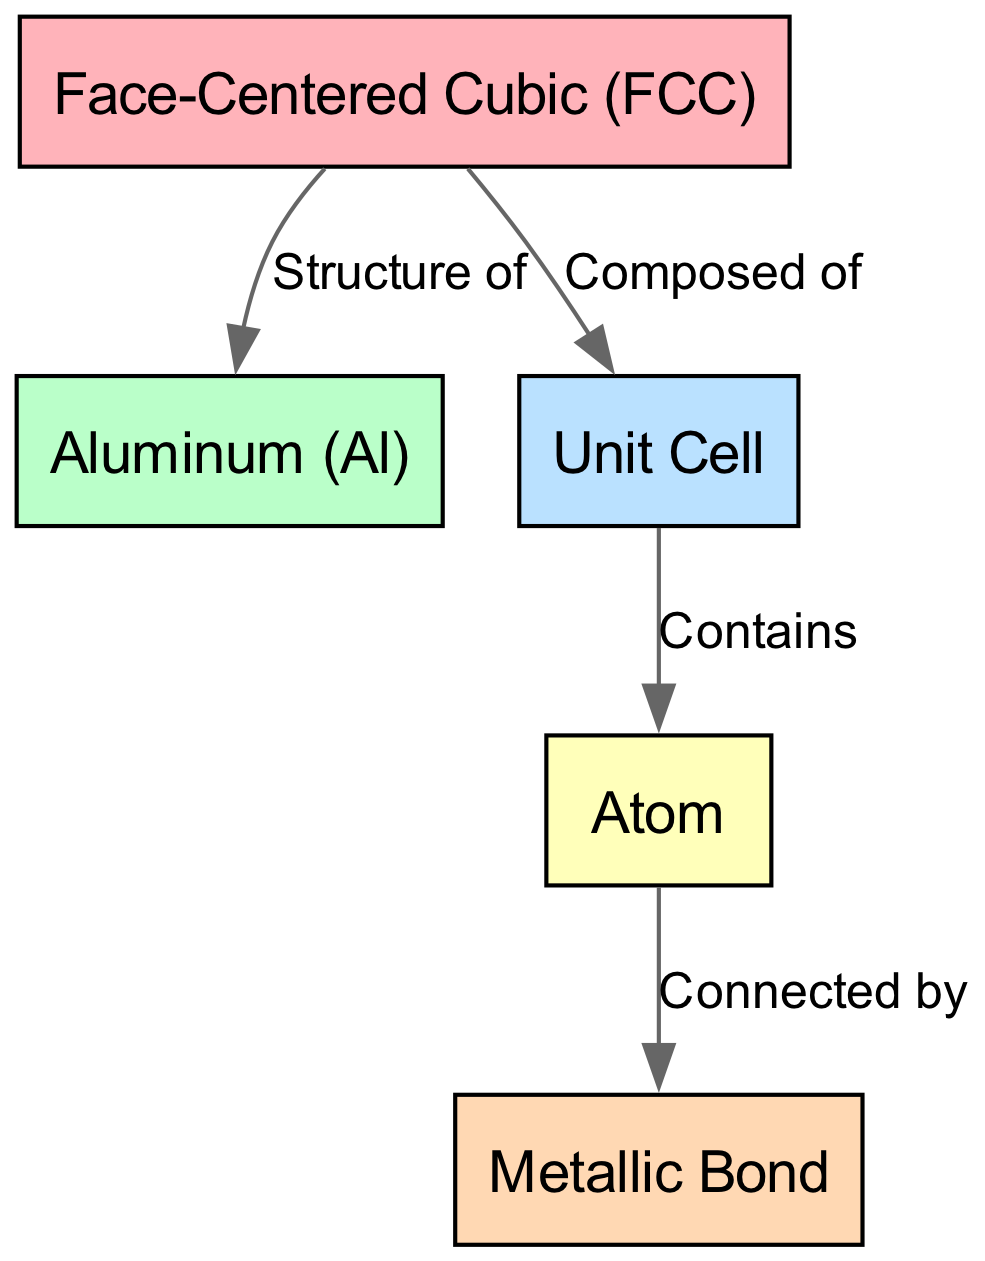What type of crystal structure is represented in the diagram? The node labeled "Face-Centered Cubic (FCC)" directly indicates the type of crystal structure.
Answer: Face-Centered Cubic (FCC) How many total nodes are there in the diagram? Counting the nodes listed in the data, there are five distinct nodes.
Answer: 5 Which metal is specified in the diagram? The node labeled "Aluminum (Al)" explicitly identifies the metal represented.
Answer: Aluminum (Al) What does the unit cell contain according to the diagram? The edge labeled "Contains" from the node "Unit Cell" to "Atom" indicates that the unit cell is comprised of atoms.
Answer: Atoms How are the atoms connected in the structure? The edge labeled "Connected by" between "Atom" and "Metallic Bond" specifies that atoms are connected by metallic bonds.
Answer: Metallic Bonds What is the relationship between Face-Centered Cubic and Aluminum? The edge labeled "Structure of" indicates that the Face-Centered Cubic structure is the structure of Aluminum.
Answer: Structure of Is there a direct connection between the Unit Cell and the Face-Centered Cubic structure? The edge labeled "Composed of" illustrates a direct connection from the Face-Centered Cubic to the Unit Cell.
Answer: Yes What type of bond is represented in the diagram? The node labeled "Metallic Bond" specifies the type of bond present in the structure.
Answer: Metallic Bond How is the diagram organized in terms of direction? The arrows indicate a top-to-bottom (topology) relationship, showing the hierarchy from crystal structure to individual atoms and bonds.
Answer: Top-to-Bottom 